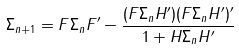<formula> <loc_0><loc_0><loc_500><loc_500>\Sigma _ { n + 1 } = F \Sigma _ { n } F ^ { \prime } - \frac { ( F \Sigma _ { n } H ^ { \prime } ) ( F \Sigma _ { n } H ^ { \prime } ) ^ { \prime } } { 1 + H \Sigma _ { n } H ^ { \prime } }</formula> 